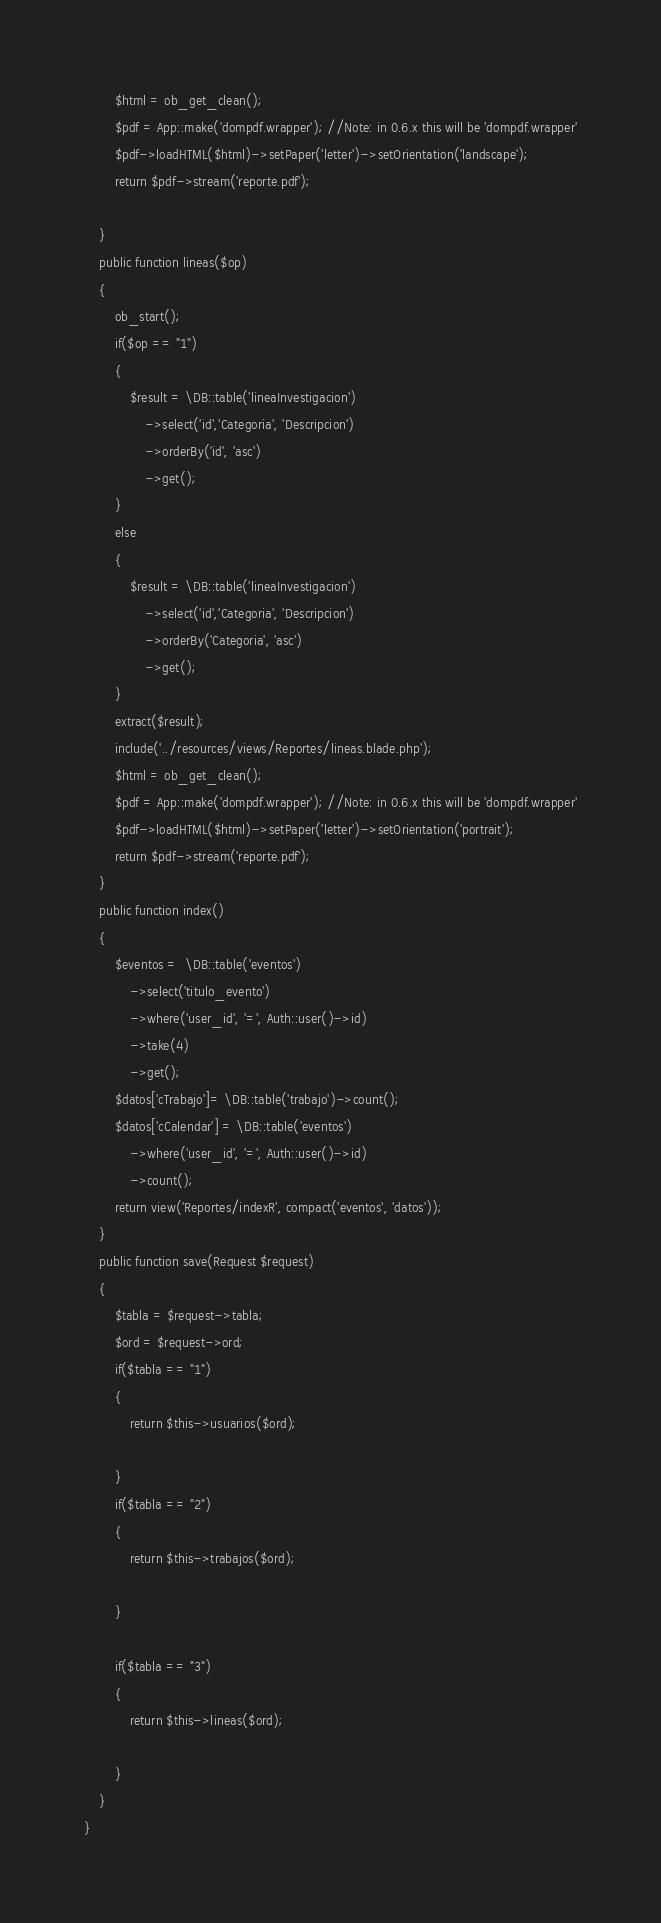Convert code to text. <code><loc_0><loc_0><loc_500><loc_500><_PHP_>        $html = ob_get_clean();
        $pdf = App::make('dompdf.wrapper'); //Note: in 0.6.x this will be 'dompdf.wrapper'
        $pdf->loadHTML($html)->setPaper('letter')->setOrientation('landscape');
        return $pdf->stream('reporte.pdf');

    }
    public function lineas($op)
    {
        ob_start();
        if($op == "1")
        {
            $result = \DB::table('lineaInvestigacion')
                ->select('id','Categoria', 'Descripcion')
                ->orderBy('id', 'asc')
                ->get();
        }
        else
        {
            $result = \DB::table('lineaInvestigacion')
                ->select('id','Categoria', 'Descripcion')
                ->orderBy('Categoria', 'asc')
                ->get();
        }
        extract($result);
        include('../resources/views/Reportes/lineas.blade.php');
        $html = ob_get_clean();
        $pdf = App::make('dompdf.wrapper'); //Note: in 0.6.x this will be 'dompdf.wrapper'
        $pdf->loadHTML($html)->setPaper('letter')->setOrientation('portrait');
        return $pdf->stream('reporte.pdf');
    }
    public function index()
    {
        $eventos =  \DB::table('eventos')
            ->select('titulo_evento')
            ->where('user_id', '=', Auth::user()->id)
            ->take(4)
            ->get();
        $datos['cTrabajo']= \DB::table('trabajo')->count();
        $datos['cCalendar'] = \DB::table('eventos')
            ->where('user_id', '=', Auth::user()->id)
            ->count();
        return view('Reportes/indexR', compact('eventos', 'datos'));
    }
    public function save(Request $request)
    {
        $tabla = $request->tabla;
        $ord = $request->ord;
        if($tabla == "1")
        {
            return $this->usuarios($ord);

        }
        if($tabla == "2")
        {
            return $this->trabajos($ord);

        }

        if($tabla == "3")
        {
            return $this->lineas($ord);

        }
    }
}</code> 